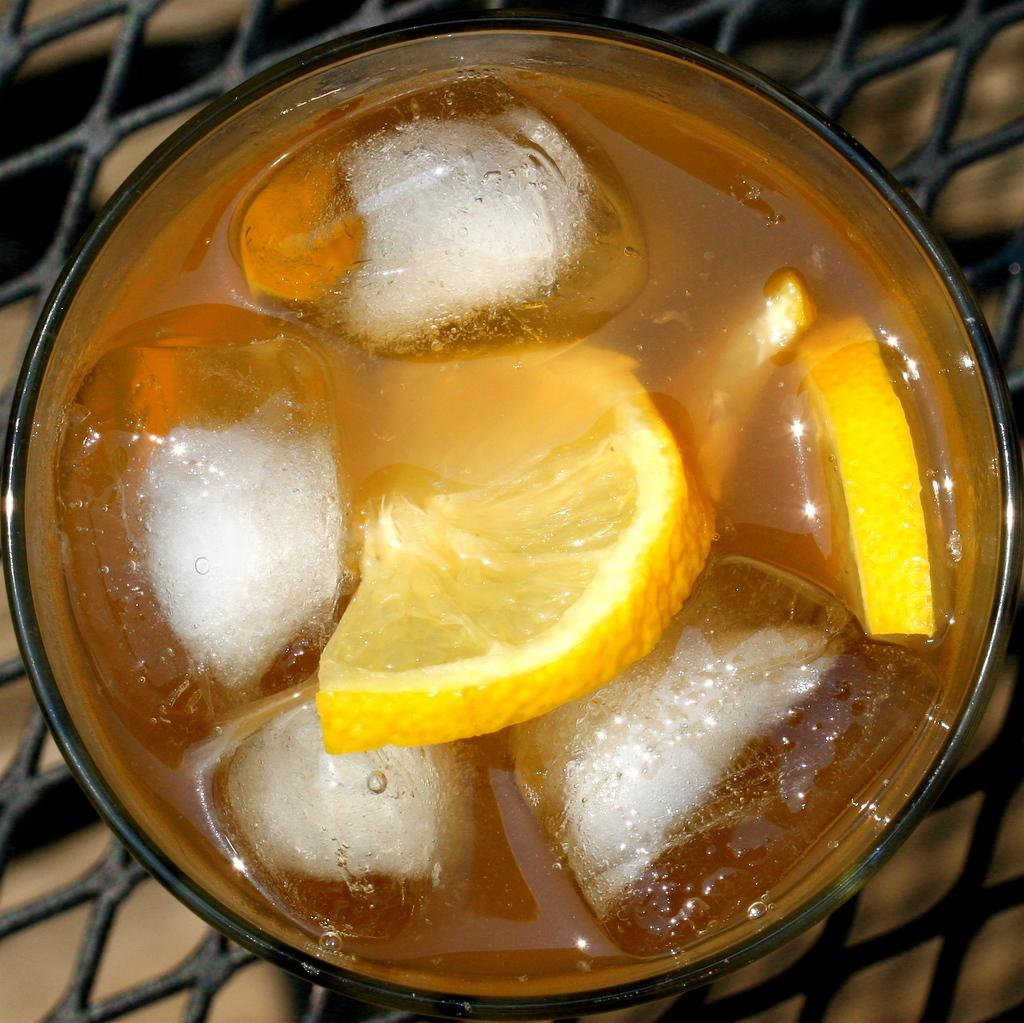What is in the bowl that is visible in the image? The bowl contains ice cubes and lemon slices. Where is the bowl located in the image? The bowl is on a metal table. What type of corn can be seen growing on the table in the image? There is no corn present in the image; the bowl contains ice cubes and lemon slices, and the table is metal. 